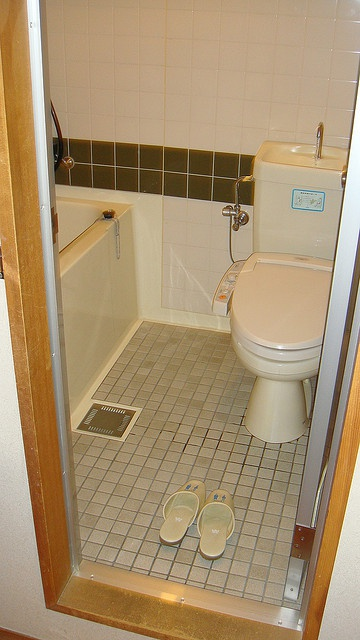Describe the objects in this image and their specific colors. I can see toilet in tan tones and sink in tan tones in this image. 